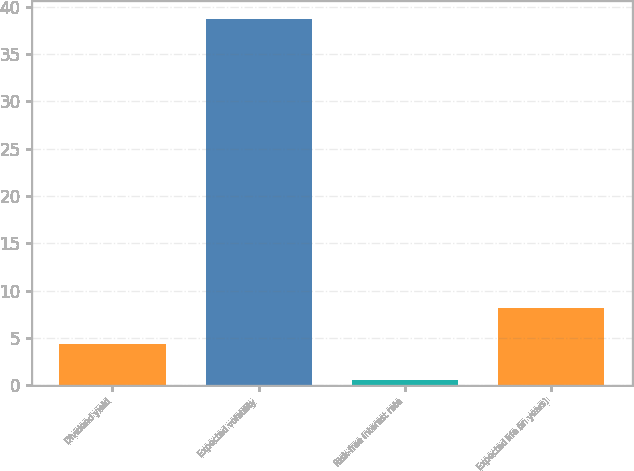Convert chart. <chart><loc_0><loc_0><loc_500><loc_500><bar_chart><fcel>Dividend yield<fcel>Expected volatility<fcel>Risk-free interest rate<fcel>Expected life (in years)<nl><fcel>4.34<fcel>38.7<fcel>0.52<fcel>8.16<nl></chart> 